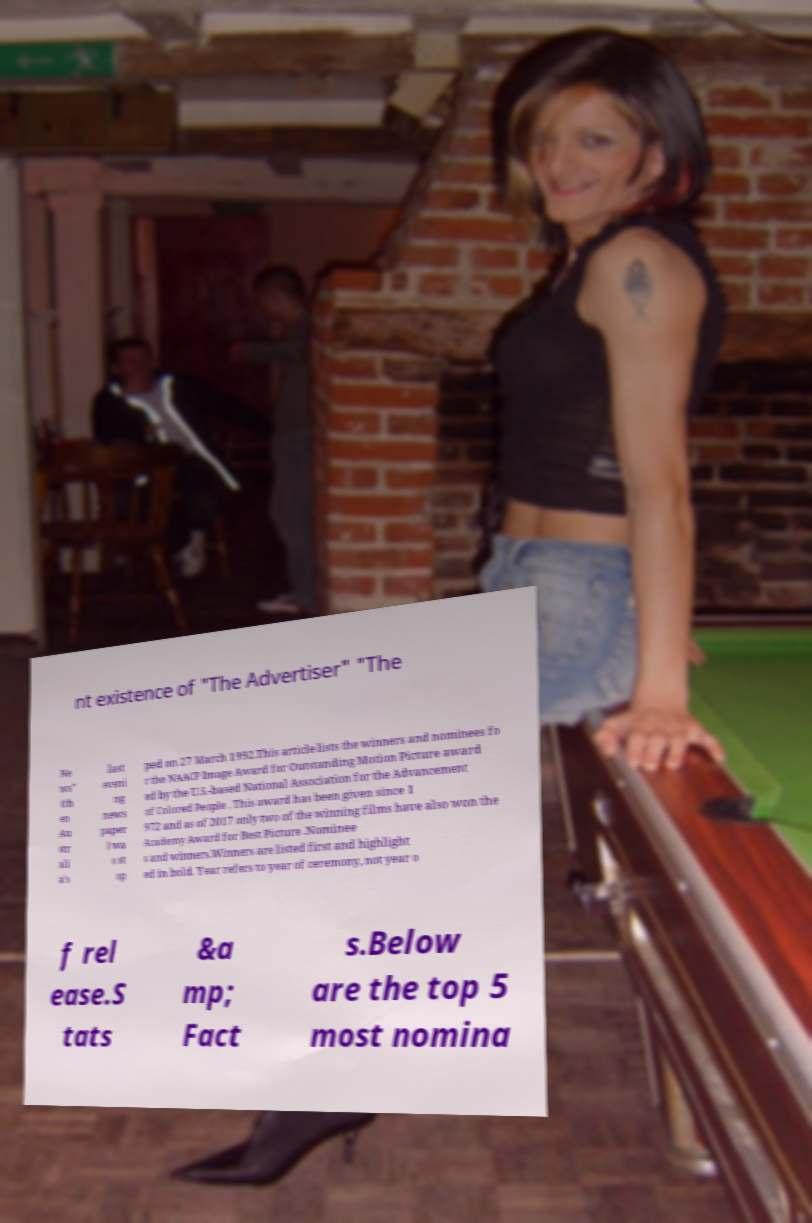What messages or text are displayed in this image? I need them in a readable, typed format. nt existence of "The Advertiser" "The Ne ws" (th en Au str ali a’s last eveni ng news paper ) wa s st op ped on 27 March 1992.This article lists the winners and nominees fo r the NAACP Image Award for Outstanding Motion Picture award ed by the U.S.-based National Association for the Advancement of Colored People . This award has been given since 1 972 and as of 2017 only two of the winning films have also won the Academy Award for Best Picture .Nominee s and winners.Winners are listed first and highlight ed in bold. Year refers to year of ceremony, not year o f rel ease.S tats &a mp; Fact s.Below are the top 5 most nomina 